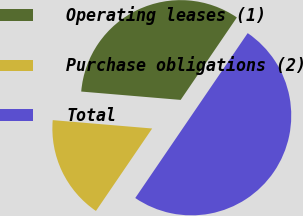Convert chart to OTSL. <chart><loc_0><loc_0><loc_500><loc_500><pie_chart><fcel>Operating leases (1)<fcel>Purchase obligations (2)<fcel>Total<nl><fcel>33.19%<fcel>16.81%<fcel>50.0%<nl></chart> 